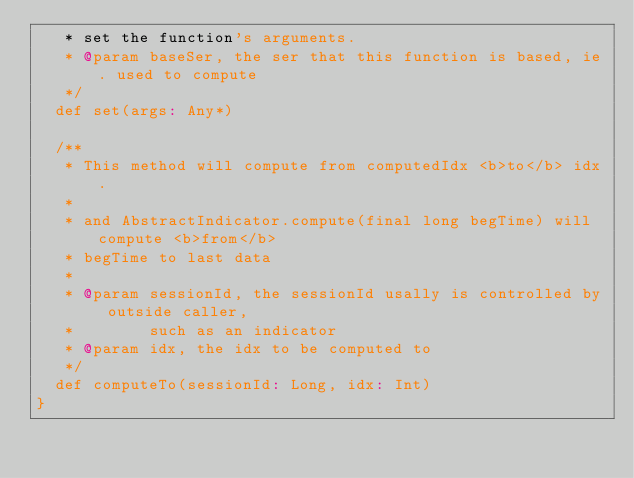Convert code to text. <code><loc_0><loc_0><loc_500><loc_500><_Scala_>   * set the function's arguments.
   * @param baseSer, the ser that this function is based, ie. used to compute
   */
  def set(args: Any*)

  /**
   * This method will compute from computedIdx <b>to</b> idx.
   *
   * and AbstractIndicator.compute(final long begTime) will compute <b>from</b>
   * begTime to last data
   *
   * @param sessionId, the sessionId usally is controlled by outside caller,
   *        such as an indicator
   * @param idx, the idx to be computed to
   */
  def computeTo(sessionId: Long, idx: Int)
}
</code> 